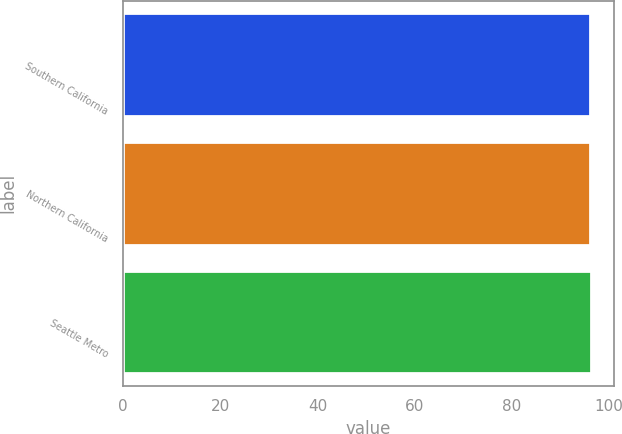Convert chart to OTSL. <chart><loc_0><loc_0><loc_500><loc_500><bar_chart><fcel>Southern California<fcel>Northern California<fcel>Seattle Metro<nl><fcel>96.1<fcel>96.2<fcel>96.3<nl></chart> 